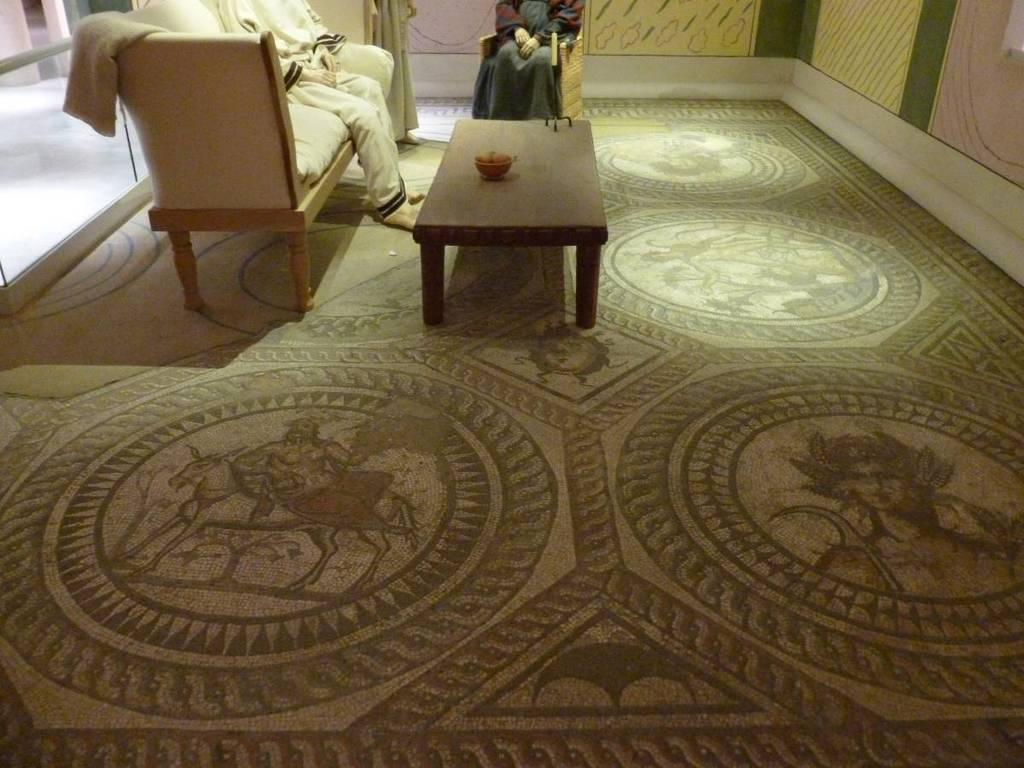Where is the setting of the image? The image is inside a house. What piece of furniture is present in the image? There is a table in the image. How many chairs are in the image? There are two chairs in the image. How many people are sitting on each chair? Two people are sitting on each chair. What can be seen on the right side of the image? There is a multi-color wall on the right side of the image. What type of unit is being sold in the image? There is no unit being sold in the image; it features a table, chairs, and a multi-color wall inside a house. How many tickets are visible in the image? There are no tickets present in the image. 